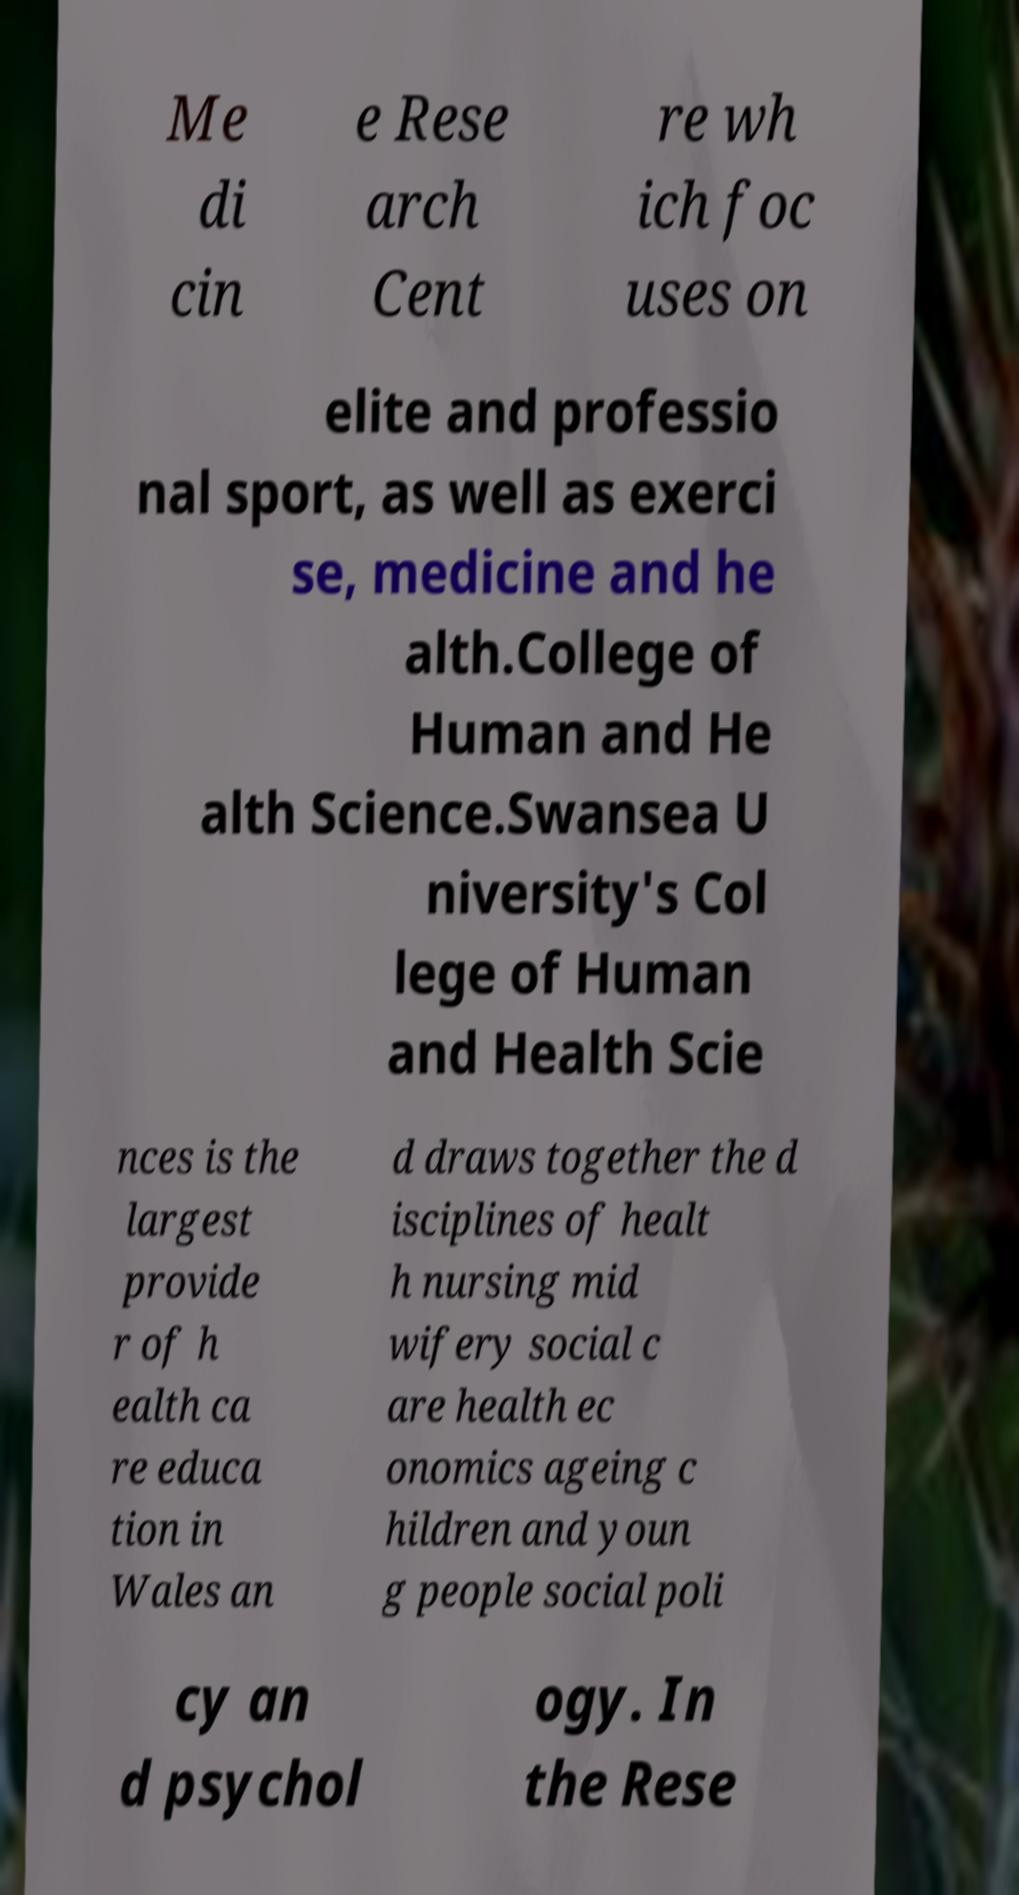Please read and relay the text visible in this image. What does it say? Me di cin e Rese arch Cent re wh ich foc uses on elite and professio nal sport, as well as exerci se, medicine and he alth.College of Human and He alth Science.Swansea U niversity's Col lege of Human and Health Scie nces is the largest provide r of h ealth ca re educa tion in Wales an d draws together the d isciplines of healt h nursing mid wifery social c are health ec onomics ageing c hildren and youn g people social poli cy an d psychol ogy. In the Rese 